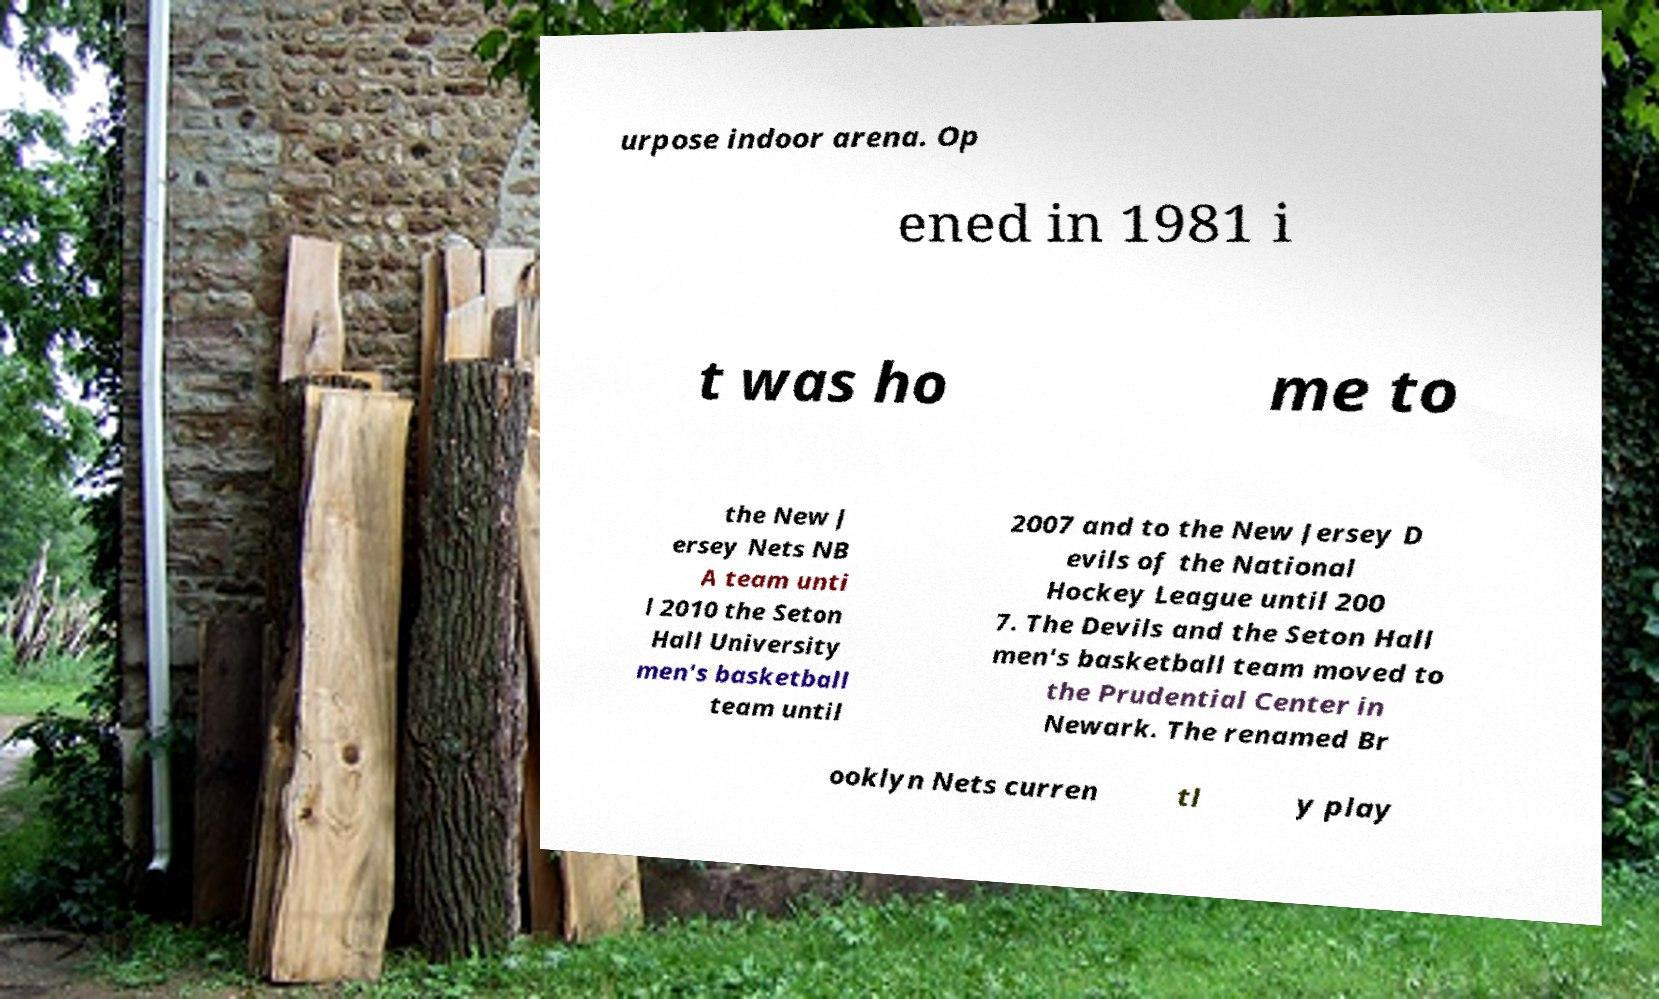Can you read and provide the text displayed in the image?This photo seems to have some interesting text. Can you extract and type it out for me? urpose indoor arena. Op ened in 1981 i t was ho me to the New J ersey Nets NB A team unti l 2010 the Seton Hall University men's basketball team until 2007 and to the New Jersey D evils of the National Hockey League until 200 7. The Devils and the Seton Hall men's basketball team moved to the Prudential Center in Newark. The renamed Br ooklyn Nets curren tl y play 